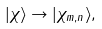<formula> <loc_0><loc_0><loc_500><loc_500>| \chi \rangle \rightarrow | \chi _ { m , n } \rangle ,</formula> 